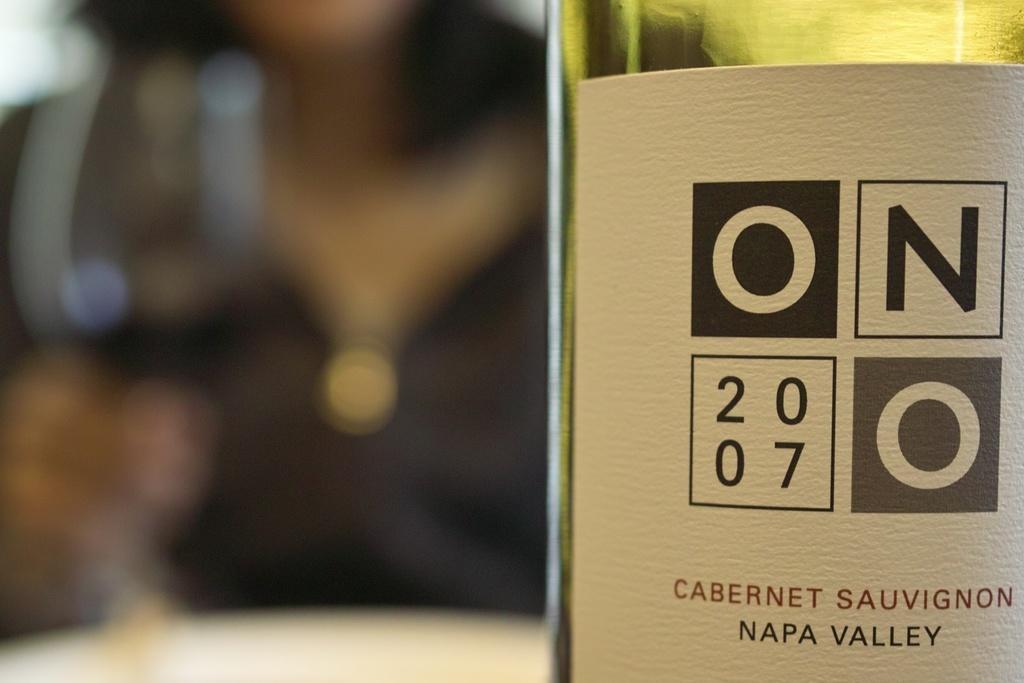How would you summarize this image in a sentence or two? On the right there is a wine bottle on the table name as "Napa Valley". In the background we can see one person. 